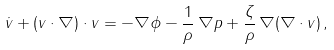<formula> <loc_0><loc_0><loc_500><loc_500>\dot { v } + ( v \cdot \nabla ) \cdot v = - \nabla \phi - \frac { 1 } { \rho } \, \nabla p + \frac { \zeta } { \rho } \, \nabla ( \nabla \cdot v ) \, ,</formula> 